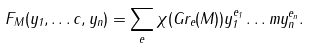Convert formula to latex. <formula><loc_0><loc_0><loc_500><loc_500>F _ { M } ( y _ { 1 } , \dots c , y _ { n } ) = \sum _ { e } \chi ( G r _ { e } ( M ) ) y _ { 1 } ^ { e _ { 1 } } \dots m y _ { n } ^ { e _ { n } } .</formula> 